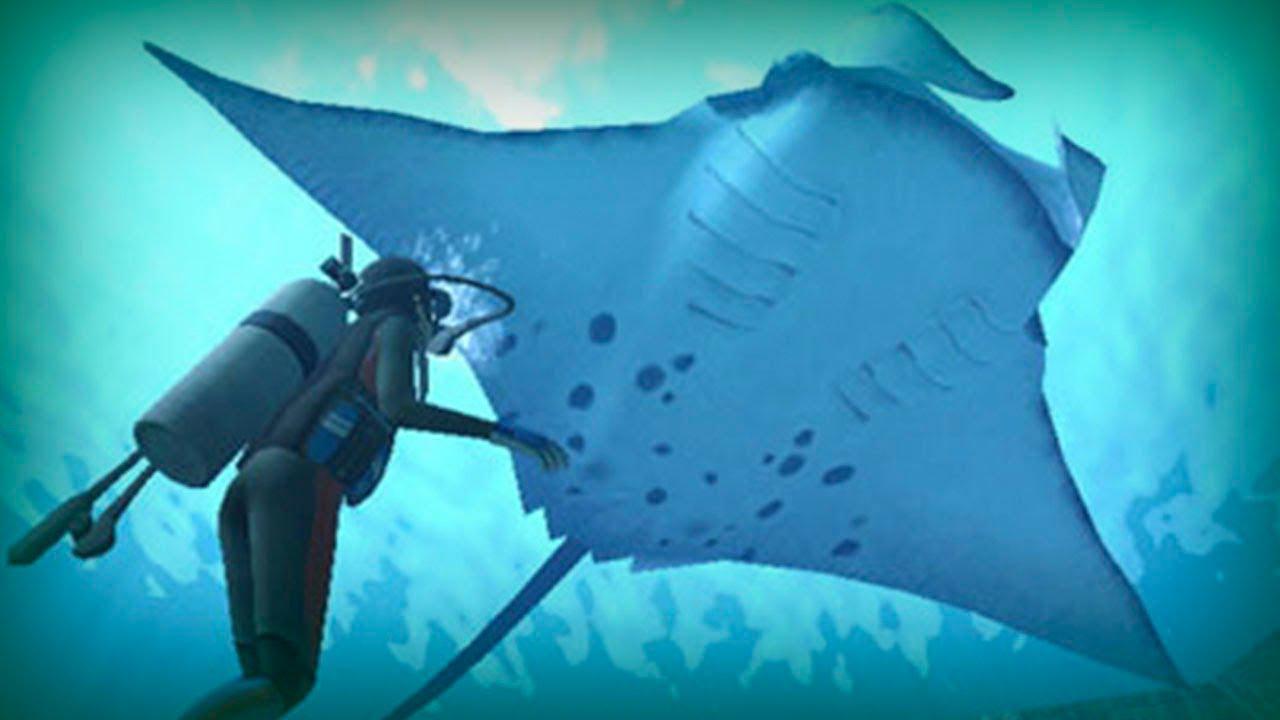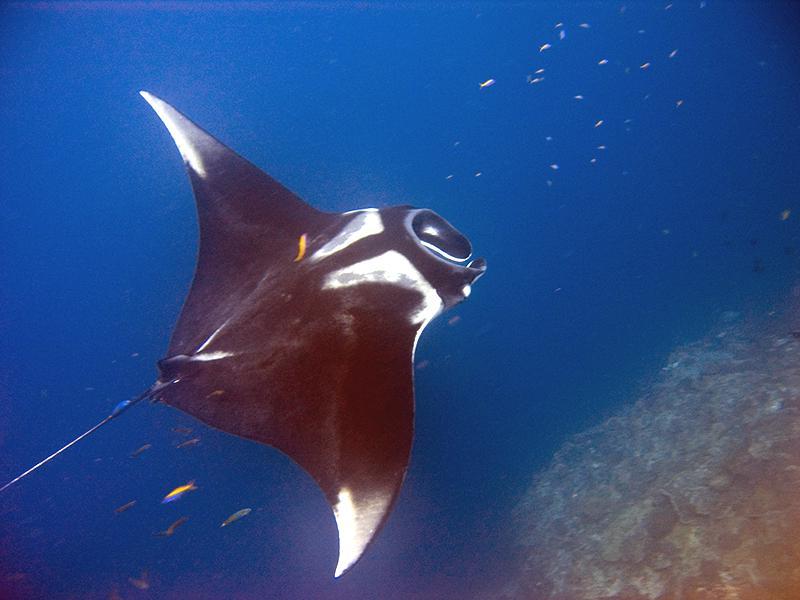The first image is the image on the left, the second image is the image on the right. For the images displayed, is the sentence "The stingray on the left is black." factually correct? Answer yes or no. No. The first image is the image on the left, the second image is the image on the right. Given the left and right images, does the statement "An image shows one mostly black stingray swimming toward the upper left." hold true? Answer yes or no. No. 